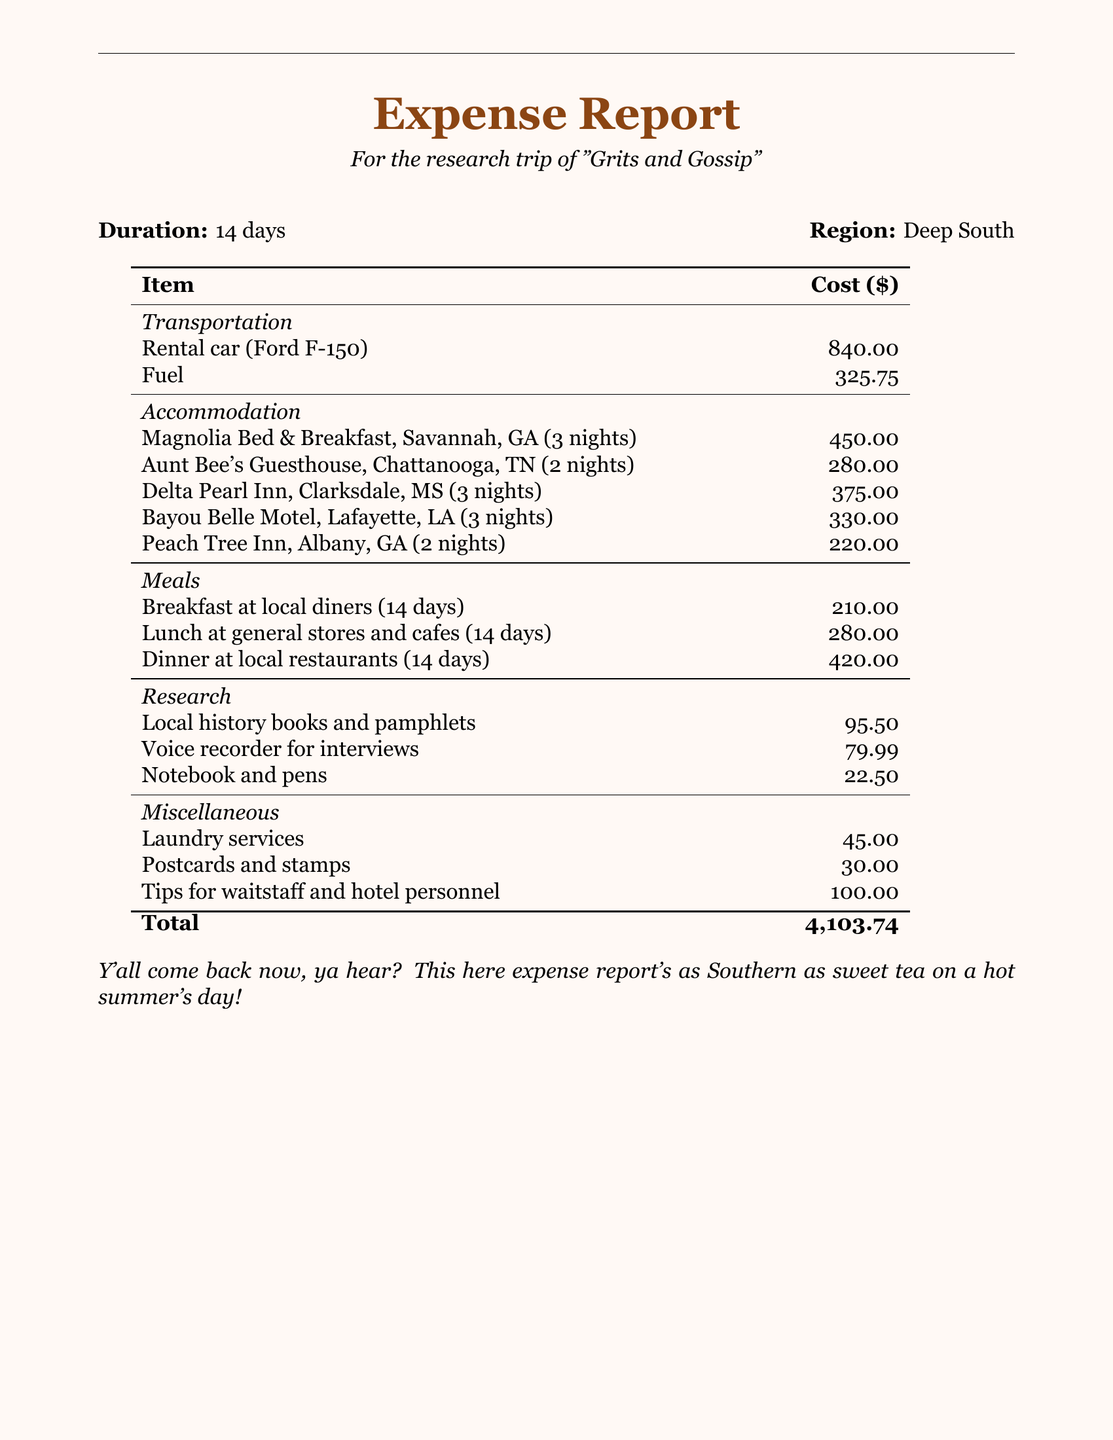What is the duration of the trip? The document states that the duration of the trip is 14 days.
Answer: 14 days What was the total cost of accommodations? The total cost of accommodations is the sum of all accommodation costs listed in the table.
Answer: 1,655.00 How much was spent on fuel? The amount spent on fuel is explicitly stated in the transportation section.
Answer: 325.75 What is the cost for breakfast in total for 14 days? The document shows that breakfast at local diners over 14 days costs a total of $210.00.
Answer: 210.00 Which diner provided the longest stay? The longest stay mentioned in the accommodation section is at the Magnolia Bed & Breakfast.
Answer: Magnolia Bed & Breakfast What is the total cost of meals? The total cost of meals is derived from the sum of breakfast, lunch, and dinner expenses for 14 days.
Answer: 910.00 What was purchased for research? The document lists local history books and pamphlets as one of the research-related expenses.
Answer: Local history books and pamphlets What does the total expense amount to? The total expense is clearly indicated at the bottom of the expense report.
Answer: 4,103.74 How much was spent on laundry services? The laundry services cost is listed under miscellaneous expenses.
Answer: 45.00 